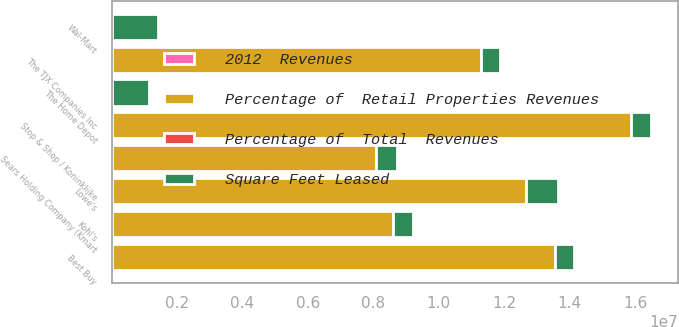Convert chart to OTSL. <chart><loc_0><loc_0><loc_500><loc_500><stacked_bar_chart><ecel><fcel>The Home Depot<fcel>Wal-Mart<fcel>Stop & Shop / Koninklijke<fcel>Best Buy<fcel>Lowe's<fcel>The TJX Companies Inc<fcel>Kohl's<fcel>Sears Holding Company (Kmart<nl><fcel>Square Feet Leased<fcel>1.135e+06<fcel>1.426e+06<fcel>633000<fcel>575000<fcel>976000<fcel>588000<fcel>610000<fcel>637000<nl><fcel>Percentage of  Retail Properties Revenues<fcel>5.1<fcel>5.1<fcel>1.5868e+07<fcel>1.3567e+07<fcel>1.2666e+07<fcel>1.1285e+07<fcel>8.589e+06<fcel>8.084e+06<nl><fcel>Percentage of  Total  Revenues<fcel>5.8<fcel>4.4<fcel>4<fcel>3.4<fcel>3.2<fcel>2.9<fcel>2.2<fcel>2.1<nl><fcel>2012  Revenues<fcel>0.8<fcel>0.6<fcel>0.6<fcel>0.5<fcel>0.5<fcel>0.4<fcel>0.3<fcel>0.3<nl></chart> 